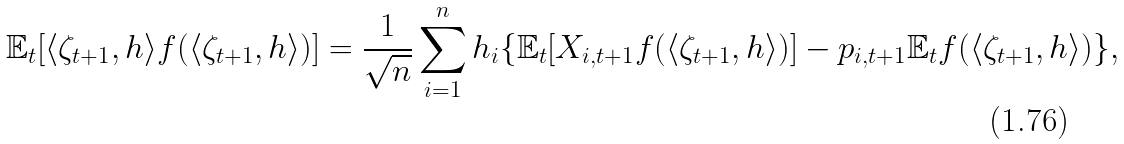<formula> <loc_0><loc_0><loc_500><loc_500>\mathbb { E } _ { t } [ \langle \zeta _ { t + 1 } , h \rangle f ( \langle \zeta _ { t + 1 } , h \rangle ) ] = \frac { 1 } { \sqrt { n } } \sum _ { i = 1 } ^ { n } h _ { i } \{ \mathbb { E } _ { t } [ X _ { i , t + 1 } f ( \langle \zeta _ { t + 1 } , h \rangle ) ] - p _ { i , t + 1 } \mathbb { E } _ { t } f ( \langle \zeta _ { t + 1 } , h \rangle ) \} ,</formula> 